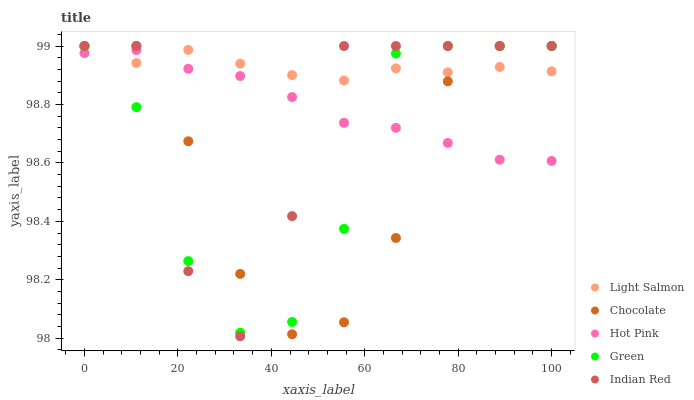Does Chocolate have the minimum area under the curve?
Answer yes or no. Yes. Does Light Salmon have the maximum area under the curve?
Answer yes or no. Yes. Does Hot Pink have the minimum area under the curve?
Answer yes or no. No. Does Hot Pink have the maximum area under the curve?
Answer yes or no. No. Is Hot Pink the smoothest?
Answer yes or no. Yes. Is Indian Red the roughest?
Answer yes or no. Yes. Is Green the smoothest?
Answer yes or no. No. Is Green the roughest?
Answer yes or no. No. Does Indian Red have the lowest value?
Answer yes or no. Yes. Does Hot Pink have the lowest value?
Answer yes or no. No. Does Chocolate have the highest value?
Answer yes or no. Yes. Does Hot Pink have the highest value?
Answer yes or no. No. Does Chocolate intersect Light Salmon?
Answer yes or no. Yes. Is Chocolate less than Light Salmon?
Answer yes or no. No. Is Chocolate greater than Light Salmon?
Answer yes or no. No. 